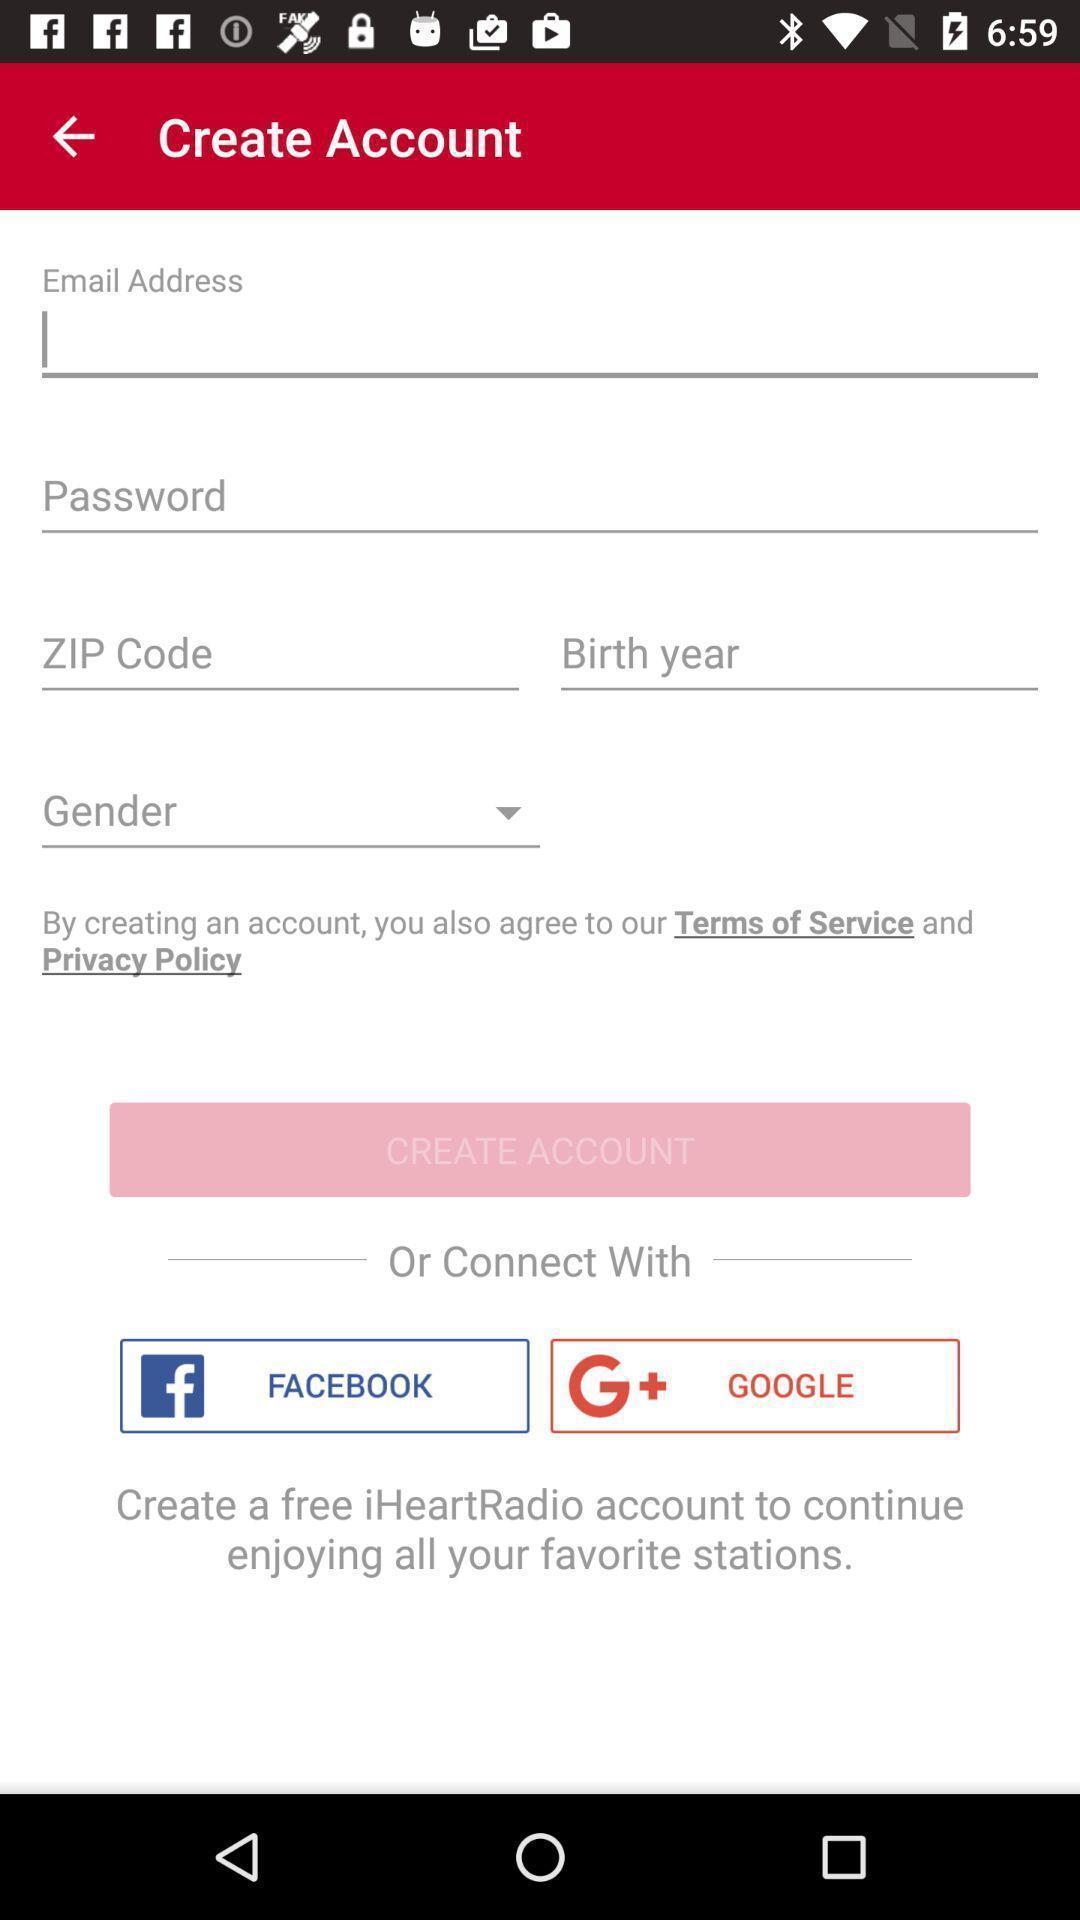Tell me what you see in this picture. Sign up page of an social app. 